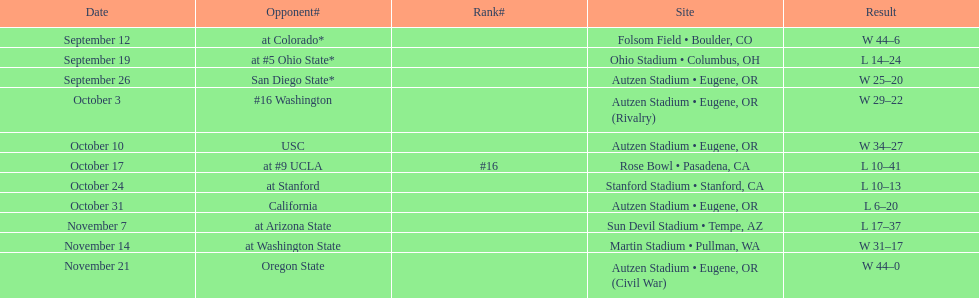Were there more wins or losses for the team? Win. 